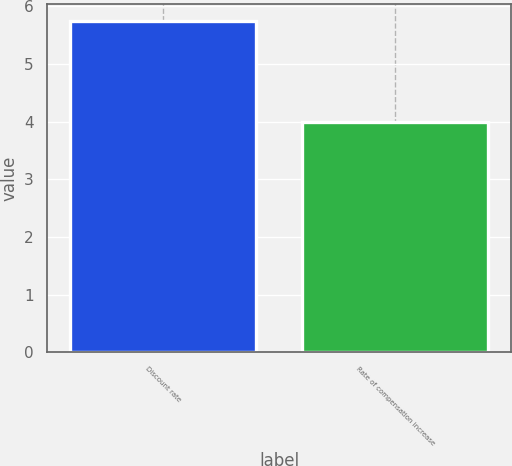<chart> <loc_0><loc_0><loc_500><loc_500><bar_chart><fcel>Discount rate<fcel>Rate of compensation increase<nl><fcel>5.75<fcel>4<nl></chart> 